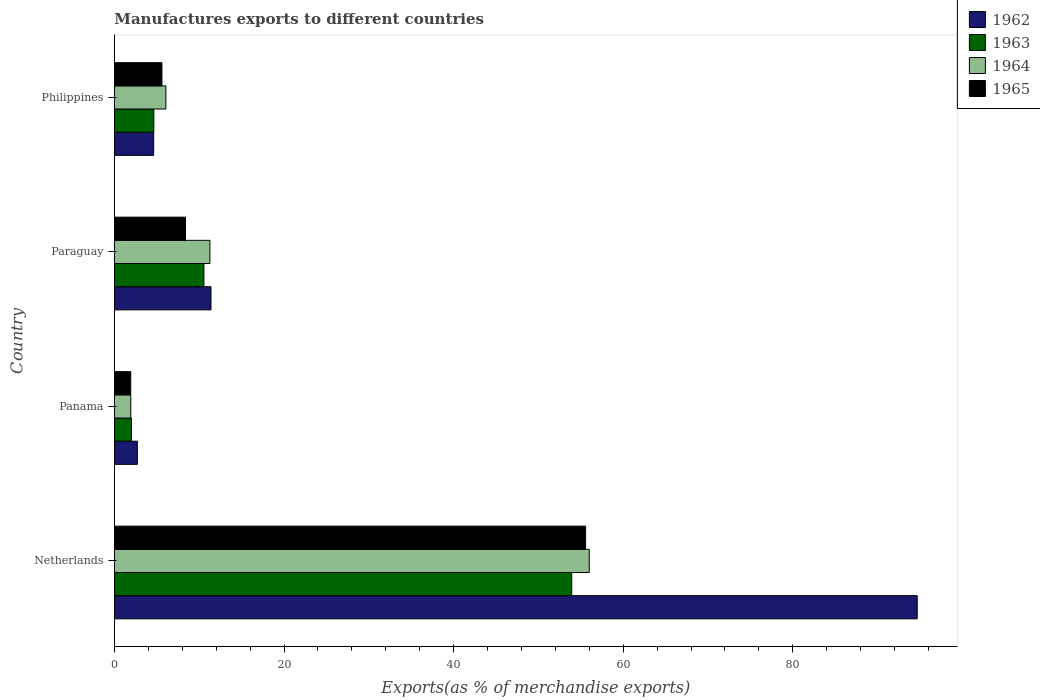How many different coloured bars are there?
Your response must be concise. 4. Are the number of bars per tick equal to the number of legend labels?
Keep it short and to the point. Yes. How many bars are there on the 2nd tick from the top?
Give a very brief answer. 4. What is the label of the 3rd group of bars from the top?
Give a very brief answer. Panama. What is the percentage of exports to different countries in 1962 in Panama?
Ensure brevity in your answer.  2.7. Across all countries, what is the maximum percentage of exports to different countries in 1963?
Offer a very short reply. 53.93. Across all countries, what is the minimum percentage of exports to different countries in 1965?
Ensure brevity in your answer.  1.92. In which country was the percentage of exports to different countries in 1964 maximum?
Make the answer very short. Netherlands. In which country was the percentage of exports to different countries in 1964 minimum?
Ensure brevity in your answer.  Panama. What is the total percentage of exports to different countries in 1963 in the graph?
Keep it short and to the point. 71.13. What is the difference between the percentage of exports to different countries in 1963 in Paraguay and that in Philippines?
Your response must be concise. 5.91. What is the difference between the percentage of exports to different countries in 1963 in Netherlands and the percentage of exports to different countries in 1962 in Philippines?
Provide a succinct answer. 49.3. What is the average percentage of exports to different countries in 1964 per country?
Give a very brief answer. 18.81. What is the difference between the percentage of exports to different countries in 1964 and percentage of exports to different countries in 1962 in Paraguay?
Offer a terse response. -0.13. In how many countries, is the percentage of exports to different countries in 1963 greater than 64 %?
Ensure brevity in your answer.  0. What is the ratio of the percentage of exports to different countries in 1965 in Netherlands to that in Philippines?
Provide a succinct answer. 9.92. What is the difference between the highest and the second highest percentage of exports to different countries in 1965?
Your answer should be very brief. 47.19. What is the difference between the highest and the lowest percentage of exports to different countries in 1964?
Keep it short and to the point. 54.07. What does the 4th bar from the top in Philippines represents?
Make the answer very short. 1962. What does the 3rd bar from the bottom in Netherlands represents?
Your response must be concise. 1964. How many bars are there?
Make the answer very short. 16. Are all the bars in the graph horizontal?
Make the answer very short. Yes. Are the values on the major ticks of X-axis written in scientific E-notation?
Ensure brevity in your answer.  No. Where does the legend appear in the graph?
Ensure brevity in your answer.  Top right. How are the legend labels stacked?
Offer a very short reply. Vertical. What is the title of the graph?
Your answer should be very brief. Manufactures exports to different countries. What is the label or title of the X-axis?
Make the answer very short. Exports(as % of merchandise exports). What is the Exports(as % of merchandise exports) of 1962 in Netherlands?
Make the answer very short. 94.68. What is the Exports(as % of merchandise exports) in 1963 in Netherlands?
Your response must be concise. 53.93. What is the Exports(as % of merchandise exports) in 1964 in Netherlands?
Provide a short and direct response. 56. What is the Exports(as % of merchandise exports) in 1965 in Netherlands?
Provide a short and direct response. 55.57. What is the Exports(as % of merchandise exports) in 1962 in Panama?
Your response must be concise. 2.7. What is the Exports(as % of merchandise exports) of 1963 in Panama?
Provide a succinct answer. 2. What is the Exports(as % of merchandise exports) in 1964 in Panama?
Offer a very short reply. 1.93. What is the Exports(as % of merchandise exports) of 1965 in Panama?
Provide a short and direct response. 1.92. What is the Exports(as % of merchandise exports) of 1962 in Paraguay?
Offer a terse response. 11.39. What is the Exports(as % of merchandise exports) in 1963 in Paraguay?
Keep it short and to the point. 10.55. What is the Exports(as % of merchandise exports) in 1964 in Paraguay?
Keep it short and to the point. 11.26. What is the Exports(as % of merchandise exports) in 1965 in Paraguay?
Your answer should be very brief. 8.38. What is the Exports(as % of merchandise exports) in 1962 in Philippines?
Offer a terse response. 4.63. What is the Exports(as % of merchandise exports) in 1963 in Philippines?
Ensure brevity in your answer.  4.64. What is the Exports(as % of merchandise exports) in 1964 in Philippines?
Your answer should be compact. 6.07. What is the Exports(as % of merchandise exports) of 1965 in Philippines?
Your answer should be very brief. 5.6. Across all countries, what is the maximum Exports(as % of merchandise exports) in 1962?
Make the answer very short. 94.68. Across all countries, what is the maximum Exports(as % of merchandise exports) in 1963?
Give a very brief answer. 53.93. Across all countries, what is the maximum Exports(as % of merchandise exports) of 1964?
Your answer should be very brief. 56. Across all countries, what is the maximum Exports(as % of merchandise exports) of 1965?
Offer a very short reply. 55.57. Across all countries, what is the minimum Exports(as % of merchandise exports) in 1962?
Offer a very short reply. 2.7. Across all countries, what is the minimum Exports(as % of merchandise exports) in 1963?
Give a very brief answer. 2. Across all countries, what is the minimum Exports(as % of merchandise exports) in 1964?
Your answer should be very brief. 1.93. Across all countries, what is the minimum Exports(as % of merchandise exports) in 1965?
Offer a very short reply. 1.92. What is the total Exports(as % of merchandise exports) in 1962 in the graph?
Provide a short and direct response. 113.4. What is the total Exports(as % of merchandise exports) of 1963 in the graph?
Offer a very short reply. 71.13. What is the total Exports(as % of merchandise exports) in 1964 in the graph?
Your response must be concise. 75.25. What is the total Exports(as % of merchandise exports) of 1965 in the graph?
Your answer should be compact. 71.47. What is the difference between the Exports(as % of merchandise exports) in 1962 in Netherlands and that in Panama?
Provide a succinct answer. 91.97. What is the difference between the Exports(as % of merchandise exports) of 1963 in Netherlands and that in Panama?
Your answer should be compact. 51.93. What is the difference between the Exports(as % of merchandise exports) of 1964 in Netherlands and that in Panama?
Offer a very short reply. 54.07. What is the difference between the Exports(as % of merchandise exports) of 1965 in Netherlands and that in Panama?
Offer a very short reply. 53.64. What is the difference between the Exports(as % of merchandise exports) in 1962 in Netherlands and that in Paraguay?
Ensure brevity in your answer.  83.29. What is the difference between the Exports(as % of merchandise exports) in 1963 in Netherlands and that in Paraguay?
Your response must be concise. 43.38. What is the difference between the Exports(as % of merchandise exports) of 1964 in Netherlands and that in Paraguay?
Provide a succinct answer. 44.74. What is the difference between the Exports(as % of merchandise exports) of 1965 in Netherlands and that in Paraguay?
Offer a terse response. 47.19. What is the difference between the Exports(as % of merchandise exports) of 1962 in Netherlands and that in Philippines?
Make the answer very short. 90.05. What is the difference between the Exports(as % of merchandise exports) of 1963 in Netherlands and that in Philippines?
Make the answer very short. 49.29. What is the difference between the Exports(as % of merchandise exports) of 1964 in Netherlands and that in Philippines?
Your answer should be very brief. 49.93. What is the difference between the Exports(as % of merchandise exports) of 1965 in Netherlands and that in Philippines?
Your response must be concise. 49.96. What is the difference between the Exports(as % of merchandise exports) of 1962 in Panama and that in Paraguay?
Your answer should be compact. -8.69. What is the difference between the Exports(as % of merchandise exports) of 1963 in Panama and that in Paraguay?
Offer a terse response. -8.55. What is the difference between the Exports(as % of merchandise exports) of 1964 in Panama and that in Paraguay?
Your answer should be compact. -9.33. What is the difference between the Exports(as % of merchandise exports) of 1965 in Panama and that in Paraguay?
Offer a terse response. -6.46. What is the difference between the Exports(as % of merchandise exports) in 1962 in Panama and that in Philippines?
Give a very brief answer. -1.92. What is the difference between the Exports(as % of merchandise exports) in 1963 in Panama and that in Philippines?
Your response must be concise. -2.64. What is the difference between the Exports(as % of merchandise exports) in 1964 in Panama and that in Philippines?
Provide a succinct answer. -4.14. What is the difference between the Exports(as % of merchandise exports) of 1965 in Panama and that in Philippines?
Offer a terse response. -3.68. What is the difference between the Exports(as % of merchandise exports) in 1962 in Paraguay and that in Philippines?
Your answer should be compact. 6.76. What is the difference between the Exports(as % of merchandise exports) in 1963 in Paraguay and that in Philippines?
Your answer should be very brief. 5.91. What is the difference between the Exports(as % of merchandise exports) in 1964 in Paraguay and that in Philippines?
Offer a terse response. 5.19. What is the difference between the Exports(as % of merchandise exports) in 1965 in Paraguay and that in Philippines?
Your answer should be compact. 2.78. What is the difference between the Exports(as % of merchandise exports) of 1962 in Netherlands and the Exports(as % of merchandise exports) of 1963 in Panama?
Your answer should be very brief. 92.67. What is the difference between the Exports(as % of merchandise exports) of 1962 in Netherlands and the Exports(as % of merchandise exports) of 1964 in Panama?
Offer a terse response. 92.75. What is the difference between the Exports(as % of merchandise exports) in 1962 in Netherlands and the Exports(as % of merchandise exports) in 1965 in Panama?
Offer a terse response. 92.75. What is the difference between the Exports(as % of merchandise exports) in 1963 in Netherlands and the Exports(as % of merchandise exports) in 1964 in Panama?
Your answer should be very brief. 52. What is the difference between the Exports(as % of merchandise exports) of 1963 in Netherlands and the Exports(as % of merchandise exports) of 1965 in Panama?
Give a very brief answer. 52.01. What is the difference between the Exports(as % of merchandise exports) in 1964 in Netherlands and the Exports(as % of merchandise exports) in 1965 in Panama?
Keep it short and to the point. 54.07. What is the difference between the Exports(as % of merchandise exports) in 1962 in Netherlands and the Exports(as % of merchandise exports) in 1963 in Paraguay?
Give a very brief answer. 84.12. What is the difference between the Exports(as % of merchandise exports) of 1962 in Netherlands and the Exports(as % of merchandise exports) of 1964 in Paraguay?
Keep it short and to the point. 83.42. What is the difference between the Exports(as % of merchandise exports) in 1962 in Netherlands and the Exports(as % of merchandise exports) in 1965 in Paraguay?
Your answer should be very brief. 86.3. What is the difference between the Exports(as % of merchandise exports) of 1963 in Netherlands and the Exports(as % of merchandise exports) of 1964 in Paraguay?
Make the answer very short. 42.67. What is the difference between the Exports(as % of merchandise exports) of 1963 in Netherlands and the Exports(as % of merchandise exports) of 1965 in Paraguay?
Keep it short and to the point. 45.55. What is the difference between the Exports(as % of merchandise exports) in 1964 in Netherlands and the Exports(as % of merchandise exports) in 1965 in Paraguay?
Provide a short and direct response. 47.62. What is the difference between the Exports(as % of merchandise exports) in 1962 in Netherlands and the Exports(as % of merchandise exports) in 1963 in Philippines?
Make the answer very short. 90.03. What is the difference between the Exports(as % of merchandise exports) of 1962 in Netherlands and the Exports(as % of merchandise exports) of 1964 in Philippines?
Keep it short and to the point. 88.61. What is the difference between the Exports(as % of merchandise exports) in 1962 in Netherlands and the Exports(as % of merchandise exports) in 1965 in Philippines?
Your response must be concise. 89.07. What is the difference between the Exports(as % of merchandise exports) in 1963 in Netherlands and the Exports(as % of merchandise exports) in 1964 in Philippines?
Make the answer very short. 47.86. What is the difference between the Exports(as % of merchandise exports) in 1963 in Netherlands and the Exports(as % of merchandise exports) in 1965 in Philippines?
Give a very brief answer. 48.33. What is the difference between the Exports(as % of merchandise exports) of 1964 in Netherlands and the Exports(as % of merchandise exports) of 1965 in Philippines?
Offer a very short reply. 50.4. What is the difference between the Exports(as % of merchandise exports) of 1962 in Panama and the Exports(as % of merchandise exports) of 1963 in Paraguay?
Give a very brief answer. -7.85. What is the difference between the Exports(as % of merchandise exports) of 1962 in Panama and the Exports(as % of merchandise exports) of 1964 in Paraguay?
Make the answer very short. -8.56. What is the difference between the Exports(as % of merchandise exports) in 1962 in Panama and the Exports(as % of merchandise exports) in 1965 in Paraguay?
Provide a succinct answer. -5.68. What is the difference between the Exports(as % of merchandise exports) of 1963 in Panama and the Exports(as % of merchandise exports) of 1964 in Paraguay?
Keep it short and to the point. -9.26. What is the difference between the Exports(as % of merchandise exports) in 1963 in Panama and the Exports(as % of merchandise exports) in 1965 in Paraguay?
Offer a terse response. -6.38. What is the difference between the Exports(as % of merchandise exports) in 1964 in Panama and the Exports(as % of merchandise exports) in 1965 in Paraguay?
Make the answer very short. -6.45. What is the difference between the Exports(as % of merchandise exports) of 1962 in Panama and the Exports(as % of merchandise exports) of 1963 in Philippines?
Ensure brevity in your answer.  -1.94. What is the difference between the Exports(as % of merchandise exports) of 1962 in Panama and the Exports(as % of merchandise exports) of 1964 in Philippines?
Provide a succinct answer. -3.36. What is the difference between the Exports(as % of merchandise exports) in 1962 in Panama and the Exports(as % of merchandise exports) in 1965 in Philippines?
Offer a very short reply. -2.9. What is the difference between the Exports(as % of merchandise exports) in 1963 in Panama and the Exports(as % of merchandise exports) in 1964 in Philippines?
Your response must be concise. -4.06. What is the difference between the Exports(as % of merchandise exports) in 1963 in Panama and the Exports(as % of merchandise exports) in 1965 in Philippines?
Offer a very short reply. -3.6. What is the difference between the Exports(as % of merchandise exports) of 1964 in Panama and the Exports(as % of merchandise exports) of 1965 in Philippines?
Make the answer very short. -3.68. What is the difference between the Exports(as % of merchandise exports) in 1962 in Paraguay and the Exports(as % of merchandise exports) in 1963 in Philippines?
Make the answer very short. 6.75. What is the difference between the Exports(as % of merchandise exports) in 1962 in Paraguay and the Exports(as % of merchandise exports) in 1964 in Philippines?
Provide a succinct answer. 5.32. What is the difference between the Exports(as % of merchandise exports) in 1962 in Paraguay and the Exports(as % of merchandise exports) in 1965 in Philippines?
Provide a succinct answer. 5.79. What is the difference between the Exports(as % of merchandise exports) in 1963 in Paraguay and the Exports(as % of merchandise exports) in 1964 in Philippines?
Give a very brief answer. 4.49. What is the difference between the Exports(as % of merchandise exports) of 1963 in Paraguay and the Exports(as % of merchandise exports) of 1965 in Philippines?
Ensure brevity in your answer.  4.95. What is the difference between the Exports(as % of merchandise exports) in 1964 in Paraguay and the Exports(as % of merchandise exports) in 1965 in Philippines?
Your response must be concise. 5.66. What is the average Exports(as % of merchandise exports) of 1962 per country?
Ensure brevity in your answer.  28.35. What is the average Exports(as % of merchandise exports) of 1963 per country?
Provide a short and direct response. 17.78. What is the average Exports(as % of merchandise exports) in 1964 per country?
Provide a succinct answer. 18.81. What is the average Exports(as % of merchandise exports) in 1965 per country?
Your answer should be very brief. 17.87. What is the difference between the Exports(as % of merchandise exports) in 1962 and Exports(as % of merchandise exports) in 1963 in Netherlands?
Offer a very short reply. 40.75. What is the difference between the Exports(as % of merchandise exports) of 1962 and Exports(as % of merchandise exports) of 1964 in Netherlands?
Offer a terse response. 38.68. What is the difference between the Exports(as % of merchandise exports) in 1962 and Exports(as % of merchandise exports) in 1965 in Netherlands?
Make the answer very short. 39.11. What is the difference between the Exports(as % of merchandise exports) in 1963 and Exports(as % of merchandise exports) in 1964 in Netherlands?
Ensure brevity in your answer.  -2.07. What is the difference between the Exports(as % of merchandise exports) of 1963 and Exports(as % of merchandise exports) of 1965 in Netherlands?
Keep it short and to the point. -1.64. What is the difference between the Exports(as % of merchandise exports) of 1964 and Exports(as % of merchandise exports) of 1965 in Netherlands?
Offer a very short reply. 0.43. What is the difference between the Exports(as % of merchandise exports) of 1962 and Exports(as % of merchandise exports) of 1963 in Panama?
Ensure brevity in your answer.  0.7. What is the difference between the Exports(as % of merchandise exports) in 1962 and Exports(as % of merchandise exports) in 1964 in Panama?
Your answer should be very brief. 0.78. What is the difference between the Exports(as % of merchandise exports) of 1962 and Exports(as % of merchandise exports) of 1965 in Panama?
Give a very brief answer. 0.78. What is the difference between the Exports(as % of merchandise exports) in 1963 and Exports(as % of merchandise exports) in 1964 in Panama?
Provide a succinct answer. 0.08. What is the difference between the Exports(as % of merchandise exports) in 1963 and Exports(as % of merchandise exports) in 1965 in Panama?
Offer a very short reply. 0.08. What is the difference between the Exports(as % of merchandise exports) of 1964 and Exports(as % of merchandise exports) of 1965 in Panama?
Provide a short and direct response. 0. What is the difference between the Exports(as % of merchandise exports) of 1962 and Exports(as % of merchandise exports) of 1963 in Paraguay?
Make the answer very short. 0.83. What is the difference between the Exports(as % of merchandise exports) in 1962 and Exports(as % of merchandise exports) in 1964 in Paraguay?
Ensure brevity in your answer.  0.13. What is the difference between the Exports(as % of merchandise exports) in 1962 and Exports(as % of merchandise exports) in 1965 in Paraguay?
Make the answer very short. 3.01. What is the difference between the Exports(as % of merchandise exports) in 1963 and Exports(as % of merchandise exports) in 1964 in Paraguay?
Offer a terse response. -0.71. What is the difference between the Exports(as % of merchandise exports) in 1963 and Exports(as % of merchandise exports) in 1965 in Paraguay?
Keep it short and to the point. 2.17. What is the difference between the Exports(as % of merchandise exports) of 1964 and Exports(as % of merchandise exports) of 1965 in Paraguay?
Your response must be concise. 2.88. What is the difference between the Exports(as % of merchandise exports) of 1962 and Exports(as % of merchandise exports) of 1963 in Philippines?
Your answer should be compact. -0.02. What is the difference between the Exports(as % of merchandise exports) in 1962 and Exports(as % of merchandise exports) in 1964 in Philippines?
Give a very brief answer. -1.44. What is the difference between the Exports(as % of merchandise exports) in 1962 and Exports(as % of merchandise exports) in 1965 in Philippines?
Your answer should be compact. -0.98. What is the difference between the Exports(as % of merchandise exports) of 1963 and Exports(as % of merchandise exports) of 1964 in Philippines?
Keep it short and to the point. -1.42. What is the difference between the Exports(as % of merchandise exports) in 1963 and Exports(as % of merchandise exports) in 1965 in Philippines?
Provide a succinct answer. -0.96. What is the difference between the Exports(as % of merchandise exports) in 1964 and Exports(as % of merchandise exports) in 1965 in Philippines?
Ensure brevity in your answer.  0.46. What is the ratio of the Exports(as % of merchandise exports) in 1962 in Netherlands to that in Panama?
Provide a short and direct response. 35.02. What is the ratio of the Exports(as % of merchandise exports) in 1963 in Netherlands to that in Panama?
Your response must be concise. 26.91. What is the ratio of the Exports(as % of merchandise exports) of 1964 in Netherlands to that in Panama?
Your answer should be compact. 29.06. What is the ratio of the Exports(as % of merchandise exports) in 1965 in Netherlands to that in Panama?
Your answer should be very brief. 28.9. What is the ratio of the Exports(as % of merchandise exports) of 1962 in Netherlands to that in Paraguay?
Your response must be concise. 8.31. What is the ratio of the Exports(as % of merchandise exports) in 1963 in Netherlands to that in Paraguay?
Your answer should be very brief. 5.11. What is the ratio of the Exports(as % of merchandise exports) of 1964 in Netherlands to that in Paraguay?
Provide a short and direct response. 4.97. What is the ratio of the Exports(as % of merchandise exports) in 1965 in Netherlands to that in Paraguay?
Offer a terse response. 6.63. What is the ratio of the Exports(as % of merchandise exports) in 1962 in Netherlands to that in Philippines?
Offer a terse response. 20.46. What is the ratio of the Exports(as % of merchandise exports) in 1963 in Netherlands to that in Philippines?
Make the answer very short. 11.61. What is the ratio of the Exports(as % of merchandise exports) of 1964 in Netherlands to that in Philippines?
Offer a very short reply. 9.23. What is the ratio of the Exports(as % of merchandise exports) in 1965 in Netherlands to that in Philippines?
Offer a terse response. 9.92. What is the ratio of the Exports(as % of merchandise exports) of 1962 in Panama to that in Paraguay?
Provide a succinct answer. 0.24. What is the ratio of the Exports(as % of merchandise exports) in 1963 in Panama to that in Paraguay?
Offer a very short reply. 0.19. What is the ratio of the Exports(as % of merchandise exports) of 1964 in Panama to that in Paraguay?
Your response must be concise. 0.17. What is the ratio of the Exports(as % of merchandise exports) in 1965 in Panama to that in Paraguay?
Keep it short and to the point. 0.23. What is the ratio of the Exports(as % of merchandise exports) in 1962 in Panama to that in Philippines?
Provide a succinct answer. 0.58. What is the ratio of the Exports(as % of merchandise exports) of 1963 in Panama to that in Philippines?
Ensure brevity in your answer.  0.43. What is the ratio of the Exports(as % of merchandise exports) of 1964 in Panama to that in Philippines?
Offer a very short reply. 0.32. What is the ratio of the Exports(as % of merchandise exports) in 1965 in Panama to that in Philippines?
Your answer should be very brief. 0.34. What is the ratio of the Exports(as % of merchandise exports) of 1962 in Paraguay to that in Philippines?
Offer a very short reply. 2.46. What is the ratio of the Exports(as % of merchandise exports) in 1963 in Paraguay to that in Philippines?
Offer a very short reply. 2.27. What is the ratio of the Exports(as % of merchandise exports) in 1964 in Paraguay to that in Philippines?
Provide a short and direct response. 1.86. What is the ratio of the Exports(as % of merchandise exports) of 1965 in Paraguay to that in Philippines?
Provide a succinct answer. 1.5. What is the difference between the highest and the second highest Exports(as % of merchandise exports) in 1962?
Provide a short and direct response. 83.29. What is the difference between the highest and the second highest Exports(as % of merchandise exports) in 1963?
Your answer should be very brief. 43.38. What is the difference between the highest and the second highest Exports(as % of merchandise exports) in 1964?
Give a very brief answer. 44.74. What is the difference between the highest and the second highest Exports(as % of merchandise exports) in 1965?
Give a very brief answer. 47.19. What is the difference between the highest and the lowest Exports(as % of merchandise exports) in 1962?
Offer a very short reply. 91.97. What is the difference between the highest and the lowest Exports(as % of merchandise exports) in 1963?
Offer a terse response. 51.93. What is the difference between the highest and the lowest Exports(as % of merchandise exports) in 1964?
Your response must be concise. 54.07. What is the difference between the highest and the lowest Exports(as % of merchandise exports) in 1965?
Make the answer very short. 53.64. 